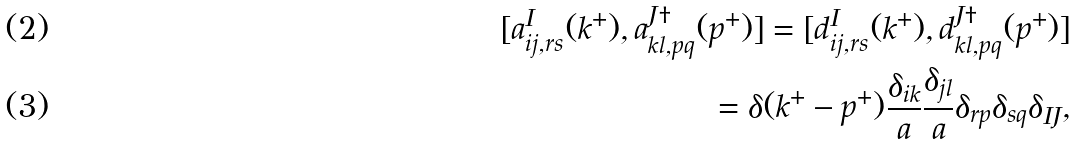<formula> <loc_0><loc_0><loc_500><loc_500>[ a _ { i j , r s } ^ { I } ( k ^ { + } ) , a ^ { J \dag } _ { k l , p q } ( p ^ { + } ) ] = [ d _ { i j , r s } ^ { I } ( k ^ { + } ) , d ^ { J \dag } _ { k l , p q } ( p ^ { + } ) ] \\ = \delta ( k ^ { + } - p ^ { + } ) \frac { \delta _ { i k } } a \frac { \delta _ { j l } } a \delta _ { r p } \delta _ { s q } \delta _ { I J } ,</formula> 